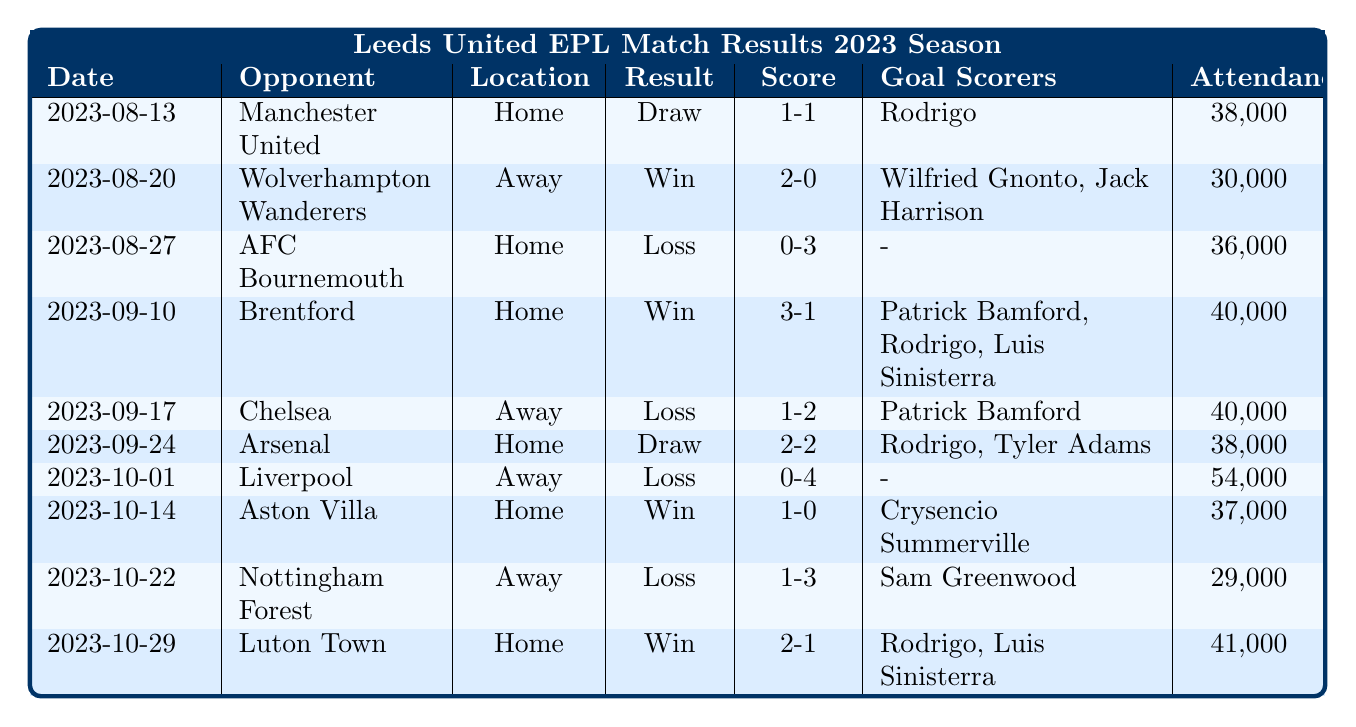What was Leeds United's score against Manchester United? The table shows the match result on 2023-08-13 against Manchester United with a score of 1-1.
Answer: 1-1 How many goals did Rodrigo score in the 2023 season according to the table? Rodrigo scored in the matches against Manchester United, Brentford, Arsenal, and Luton Town. This totals to 4 goals.
Answer: 4 Did Leeds United win any matches at home in the 2023 season? The matches Leeds played at home were against Manchester United (Draw), AFC Bournemouth (Loss), Brentford (Win), Arsenal (Draw), Aston Villa (Win), and Luton Town (Win). Since they won against Brentford, Aston Villa, and Luton Town, the answer is yes.
Answer: Yes What was the attendance for the match against Arsenal? Referring to the table for the match on 2023-09-24 against Arsenal, the attendance was 38,000.
Answer: 38,000 How many matches did Leeds United lose in the month of October? Leeds played two matches in October: against Liverpool (Loss) and Nottingham Forest (Loss). Therefore, they lost both matches in October.
Answer: 2 What is the average attendance for Leeds United's home matches based on the data? The home matches listed are against Manchester United (38,000), AFC Bournemouth (36,000), Brentford (40,000), Arsenal (38,000), Aston Villa (37,000), and Luton Town (41,000). The total attendance is 230,000 across 6 matches, yielding an average of 230,000 / 6 = 38,333.
Answer: 38,333 How many goals did Leeds score in their winning matches? Leeds won matches against Wolverhampton Wanderers (2 goals), Brentford (3 goals), Aston Villa (1 goal), and Luton Town (2 goals). Summing these gives 2 + 3 + 1 + 2 = 8 goals scored in winning matches.
Answer: 8 What was the result of the match against Chelsea on September 17? The table indicates that Leeds United played Chelsea away on 2023-09-17, resulting in a loss with a score of 1-2.
Answer: Loss How did Leeds United fare against teams that were at home versus away? Leeds United played 6 home matches where they had 3 wins (Brentford, Aston Villa, Luton Town), 2 draws (Manchester United, Arsenal), and 1 loss (AFC Bournemouth). They lost all 3 away matches against Wolverhampton Wanderers, Chelsea, and Liverpool.
Answer: Better at home Which opponent did Leeds United score the most goals against in a single match? Leeds scored the most goals in the match against Brentford on 2023-09-10 where they scored 3 goals (winning the match 3-1).
Answer: Brentford 